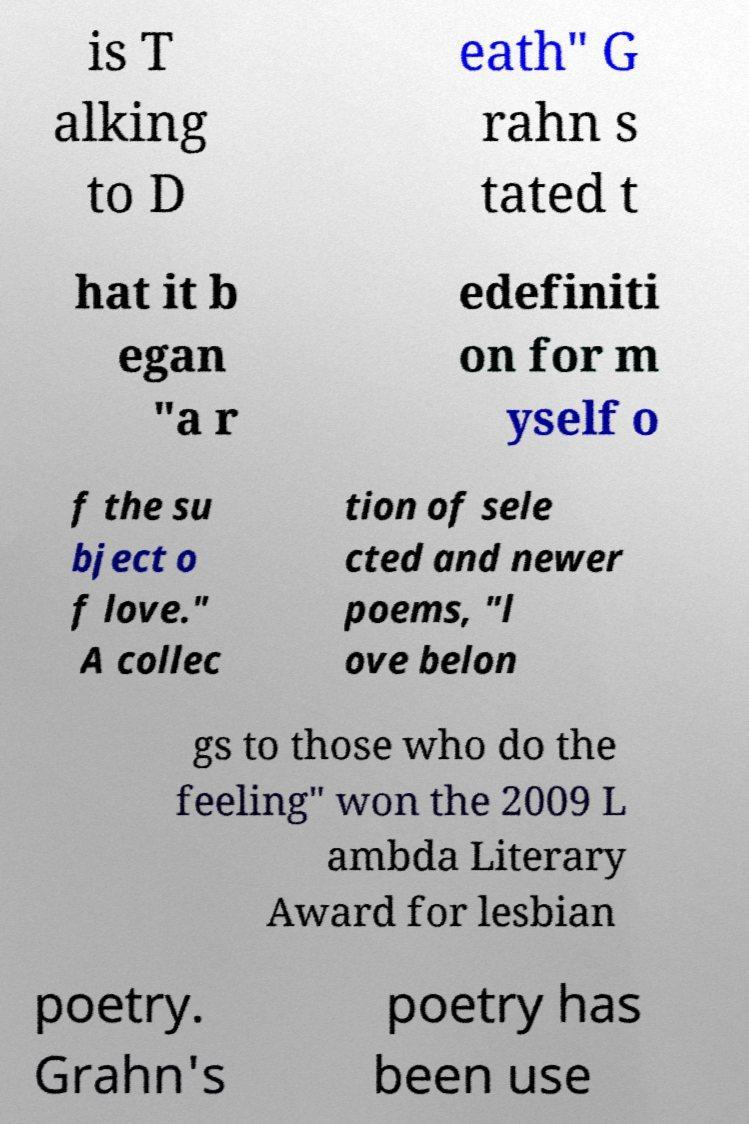Could you extract and type out the text from this image? is T alking to D eath" G rahn s tated t hat it b egan "a r edefiniti on for m yself o f the su bject o f love." A collec tion of sele cted and newer poems, "l ove belon gs to those who do the feeling" won the 2009 L ambda Literary Award for lesbian poetry. Grahn's poetry has been use 